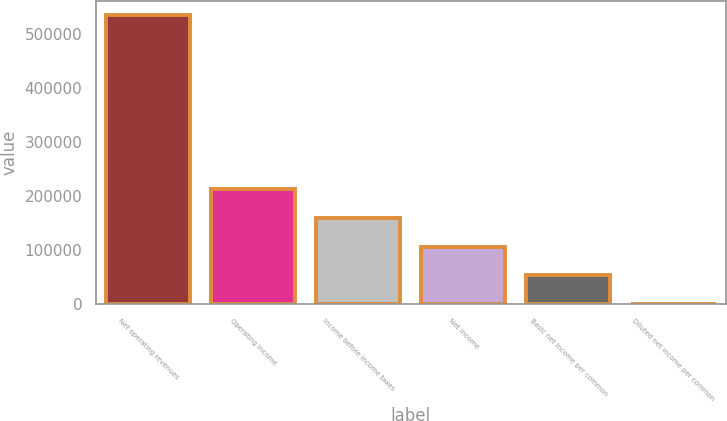Convert chart. <chart><loc_0><loc_0><loc_500><loc_500><bar_chart><fcel>Net operating revenues<fcel>Operating income<fcel>Income before income taxes<fcel>Net income<fcel>Basic net income per common<fcel>Diluted net income per common<nl><fcel>535431<fcel>214173<fcel>160630<fcel>107087<fcel>53543.6<fcel>0.51<nl></chart> 